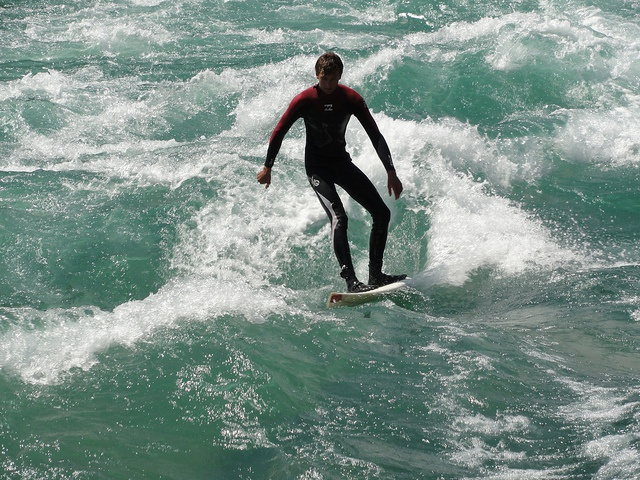Describe the objects in this image and their specific colors. I can see people in teal, black, darkgray, gray, and lightgray tones and surfboard in teal, gray, ivory, darkgreen, and black tones in this image. 